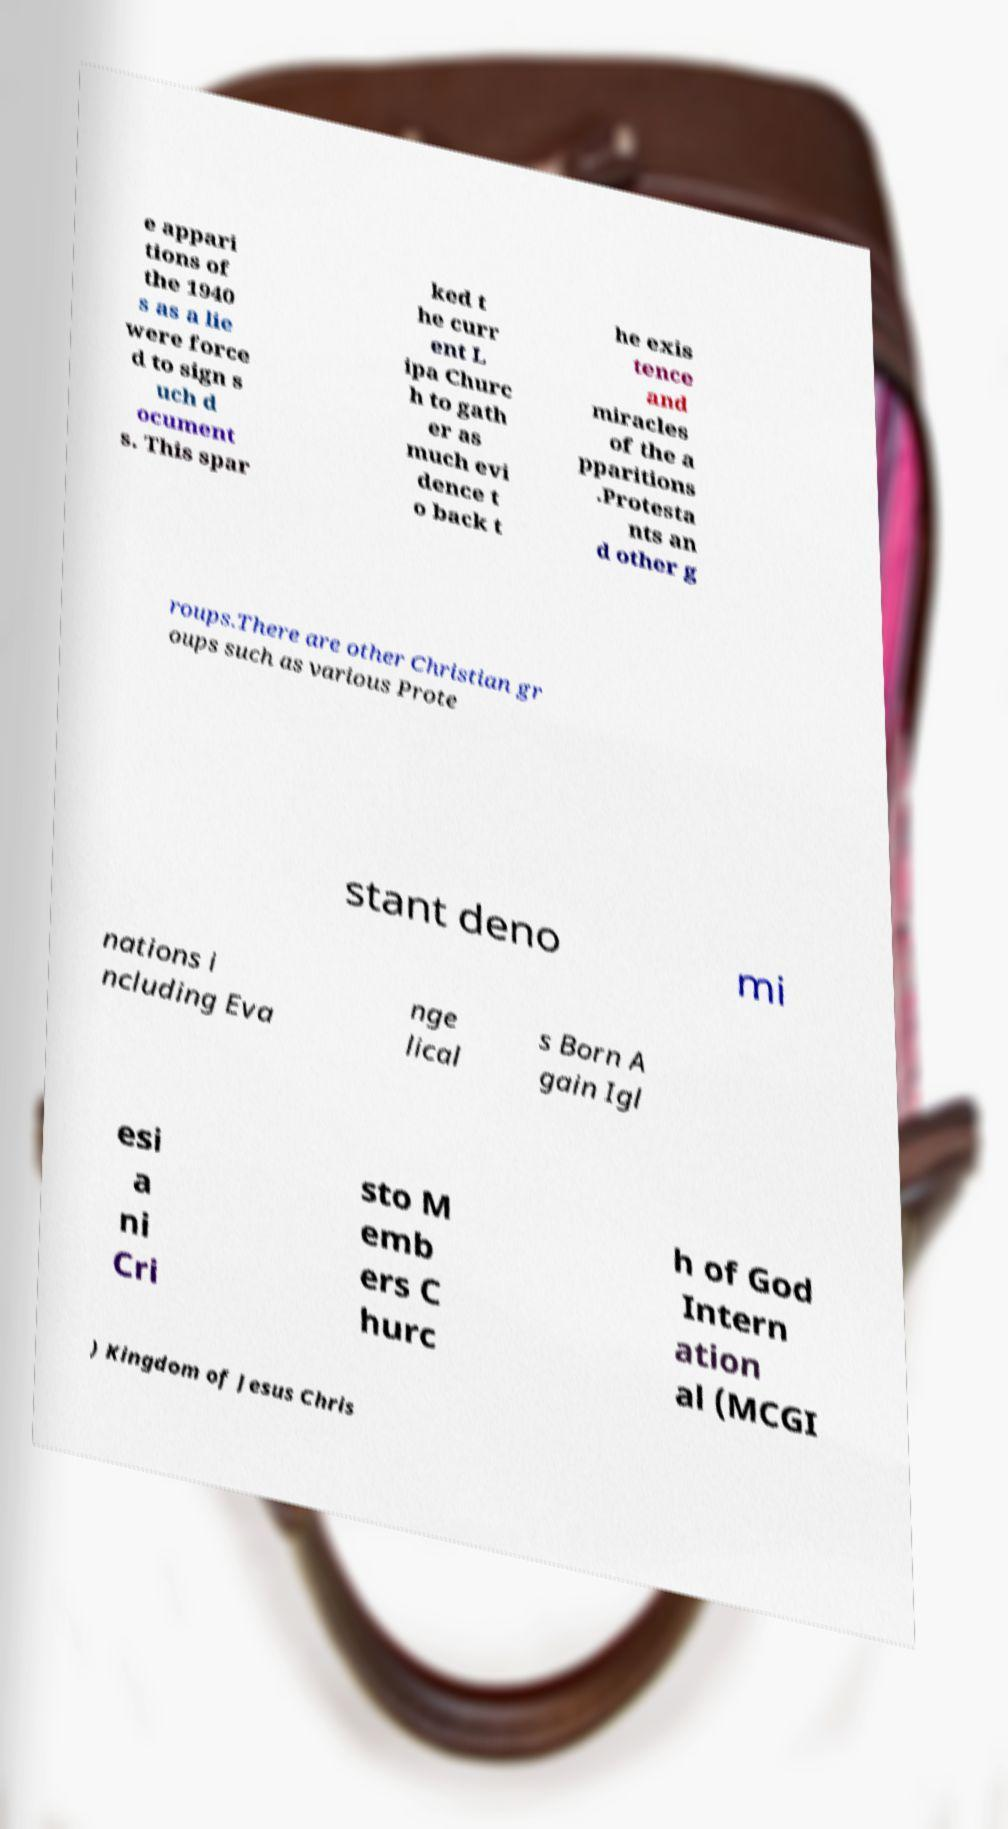Please identify and transcribe the text found in this image. e appari tions of the 1940 s as a lie were force d to sign s uch d ocument s. This spar ked t he curr ent L ipa Churc h to gath er as much evi dence t o back t he exis tence and miracles of the a pparitions .Protesta nts an d other g roups.There are other Christian gr oups such as various Prote stant deno mi nations i ncluding Eva nge lical s Born A gain Igl esi a ni Cri sto M emb ers C hurc h of God Intern ation al (MCGI ) Kingdom of Jesus Chris 